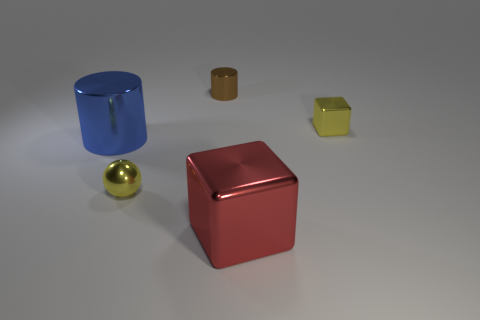Are there fewer cubes than brown objects?
Provide a succinct answer. No. There is a large metallic object that is to the left of the shiny cube in front of the blue metal object; what color is it?
Offer a terse response. Blue. What is the big red thing to the left of the yellow metal object that is behind the big thing that is left of the red metal block made of?
Your response must be concise. Metal. Do the metallic cylinder that is behind the blue metal cylinder and the red thing have the same size?
Offer a very short reply. No. There is a small yellow object on the right side of the tiny brown metal cylinder; what is it made of?
Offer a terse response. Metal. Are there more small red metal objects than big cubes?
Ensure brevity in your answer.  No. What number of things are yellow metallic things in front of the big blue cylinder or tiny balls?
Your response must be concise. 1. What number of small yellow metal things are to the left of the yellow block that is behind the big blue metallic cylinder?
Offer a terse response. 1. There is a yellow metallic thing behind the cylinder to the left of the small yellow metal thing left of the big red metallic object; what size is it?
Your answer should be very brief. Small. There is a small thing that is in front of the large blue cylinder; is it the same color as the small block?
Provide a short and direct response. Yes. 